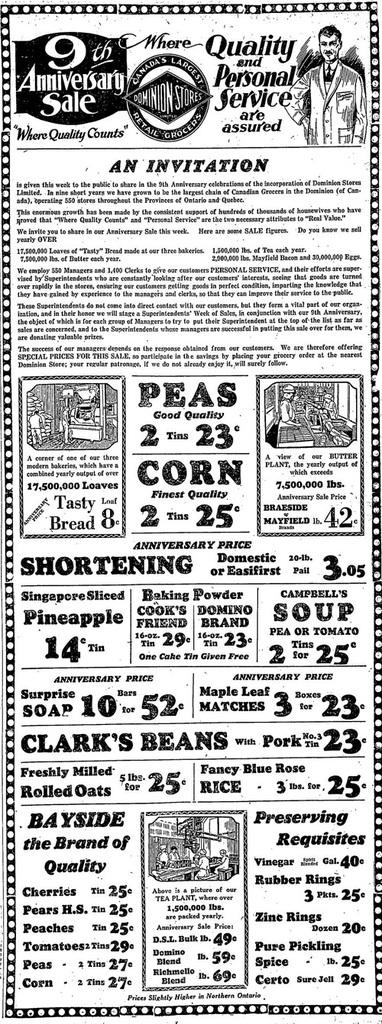What is the main subject of the image? The main subject of the image is an advertisement. What can be seen on the advertisement? The advertisement has text written on it. How many birds are talking to each other in the image? There are no birds present in the image, and therefore no such activity can be observed. 